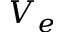Convert formula to latex. <formula><loc_0><loc_0><loc_500><loc_500>V _ { e }</formula> 